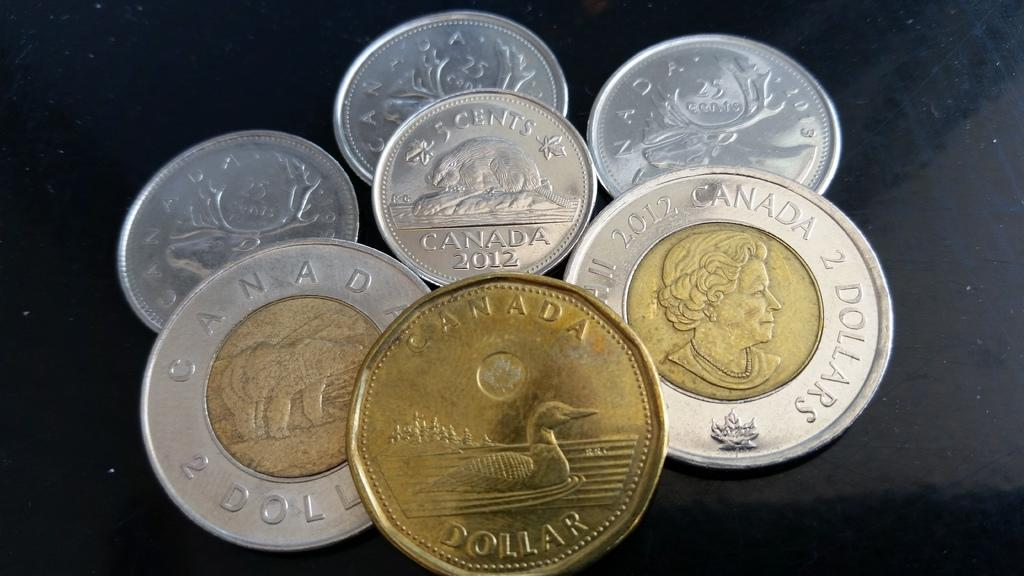<image>
Offer a succinct explanation of the picture presented. Canada dollar coins and two dollar coins on a table 